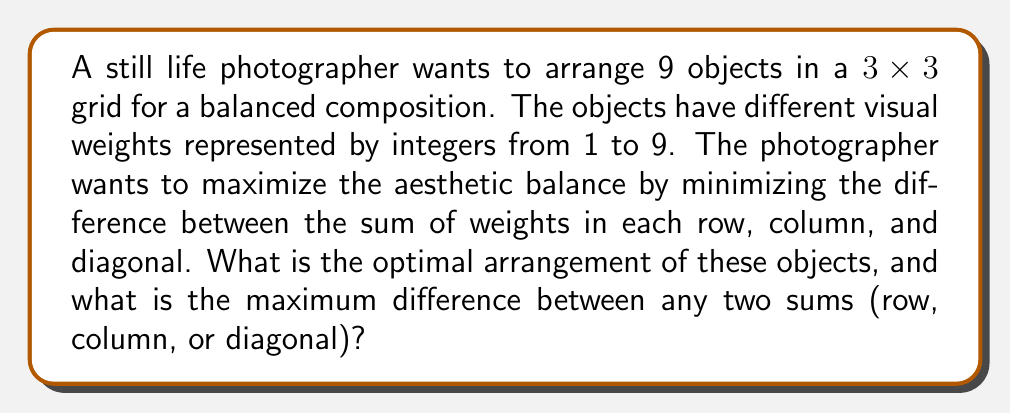Help me with this question. To solve this problem, we need to use concepts from graph theory and combinatorics. The optimal arrangement for a 3x3 grid with numbers 1 to 9 is known as a magic square.

Steps to solve:

1) In a 3x3 magic square, the sum of each row, column, and diagonal is the same. This sum is called the magic constant.

2) The magic constant for a 3x3 grid with numbers 1 to 9 is calculated as:
   $$ \frac{n(n^2 + 1)}{2} = \frac{3(3^2 + 1)}{2} = \frac{3(10)}{2} = 15 $$

3) The optimal arrangement that achieves this constant sum is:

   [asy]
   size(100);
   for(int i=0; i<3; ++i)
     for(int j=0; j<3; ++j)
       draw((i,j)--(i+1,j)--(i+1,j+1)--(i,j+1)--cycle);
   label("8", (0.5,2.5));
   label("1", (1.5,2.5));
   label("6", (2.5,2.5));
   label("3", (0.5,1.5));
   label("5", (1.5,1.5));
   label("7", (2.5,1.5));
   label("4", (0.5,0.5));
   label("9", (1.5,0.5));
   label("2", (2.5,0.5));
   [/asy]

4) In this arrangement:
   - Each row sums to 15: 8+1+6 = 3+5+7 = 4+9+2 = 15
   - Each column sums to 15: 8+3+4 = 1+5+9 = 6+7+2 = 15
   - Each diagonal sums to 15: 8+5+2 = 6+5+4 = 15

5) Since all sums are equal, the maximum difference between any two sums is 0.

This arrangement ensures that the visual weights are perfectly balanced across all directions, creating an aesthetically pleasing composition for the still life photograph.
Answer: The optimal arrangement is:
8 1 6
3 5 7
4 9 2

The maximum difference between any two sums (row, column, or diagonal) is 0. 